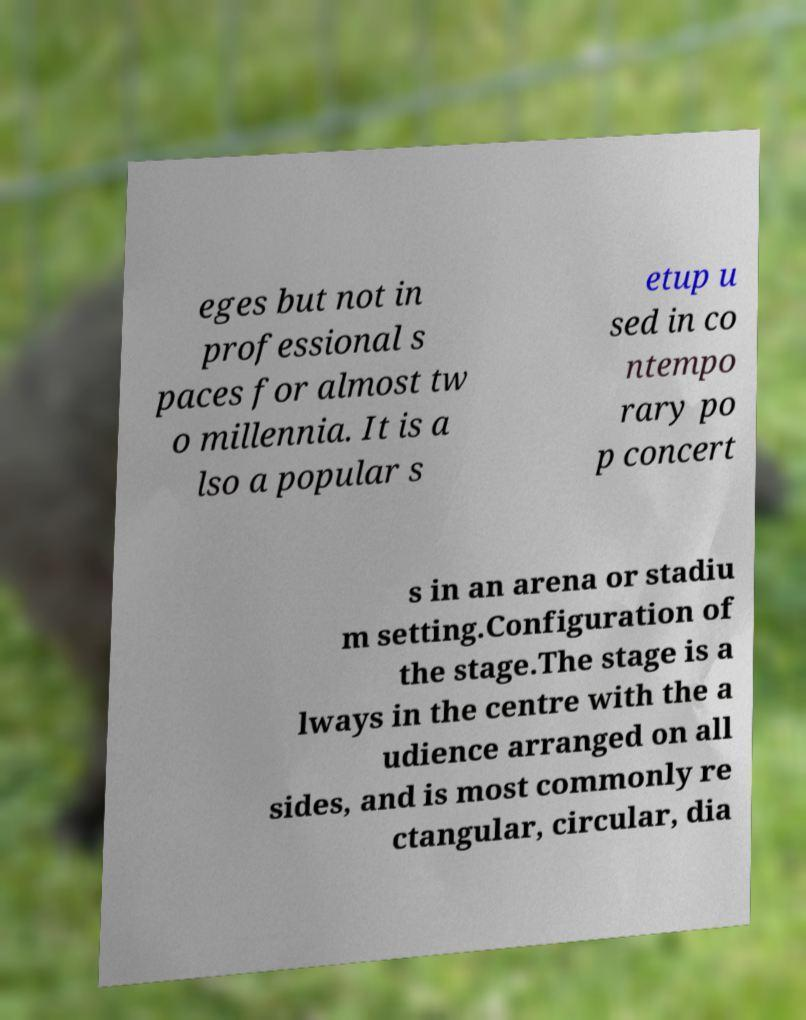Please read and relay the text visible in this image. What does it say? eges but not in professional s paces for almost tw o millennia. It is a lso a popular s etup u sed in co ntempo rary po p concert s in an arena or stadiu m setting.Configuration of the stage.The stage is a lways in the centre with the a udience arranged on all sides, and is most commonly re ctangular, circular, dia 